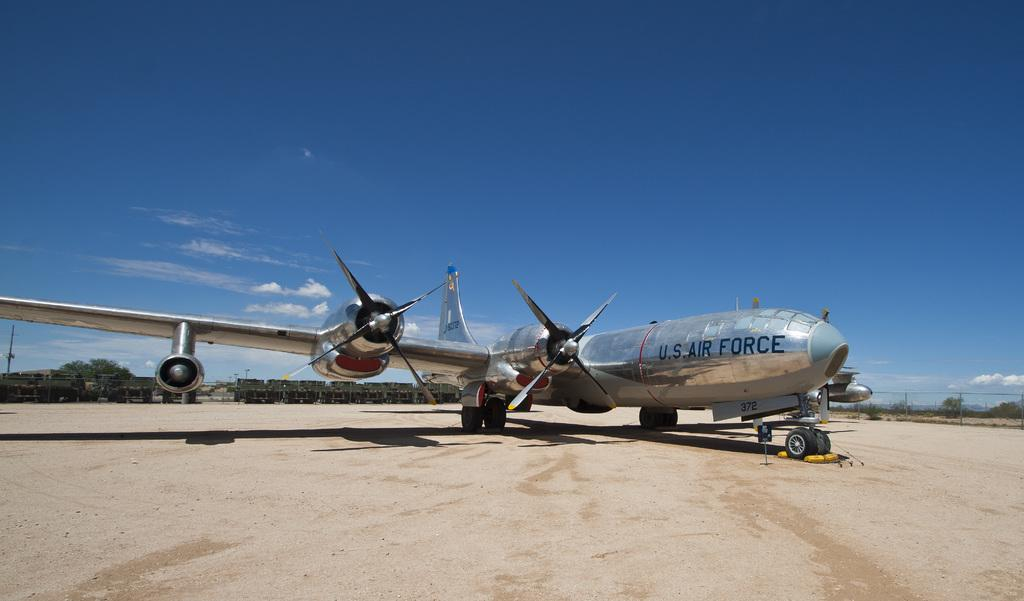Provide a one-sentence caption for the provided image. A silver U.S. Air Force plane is at at military base. 